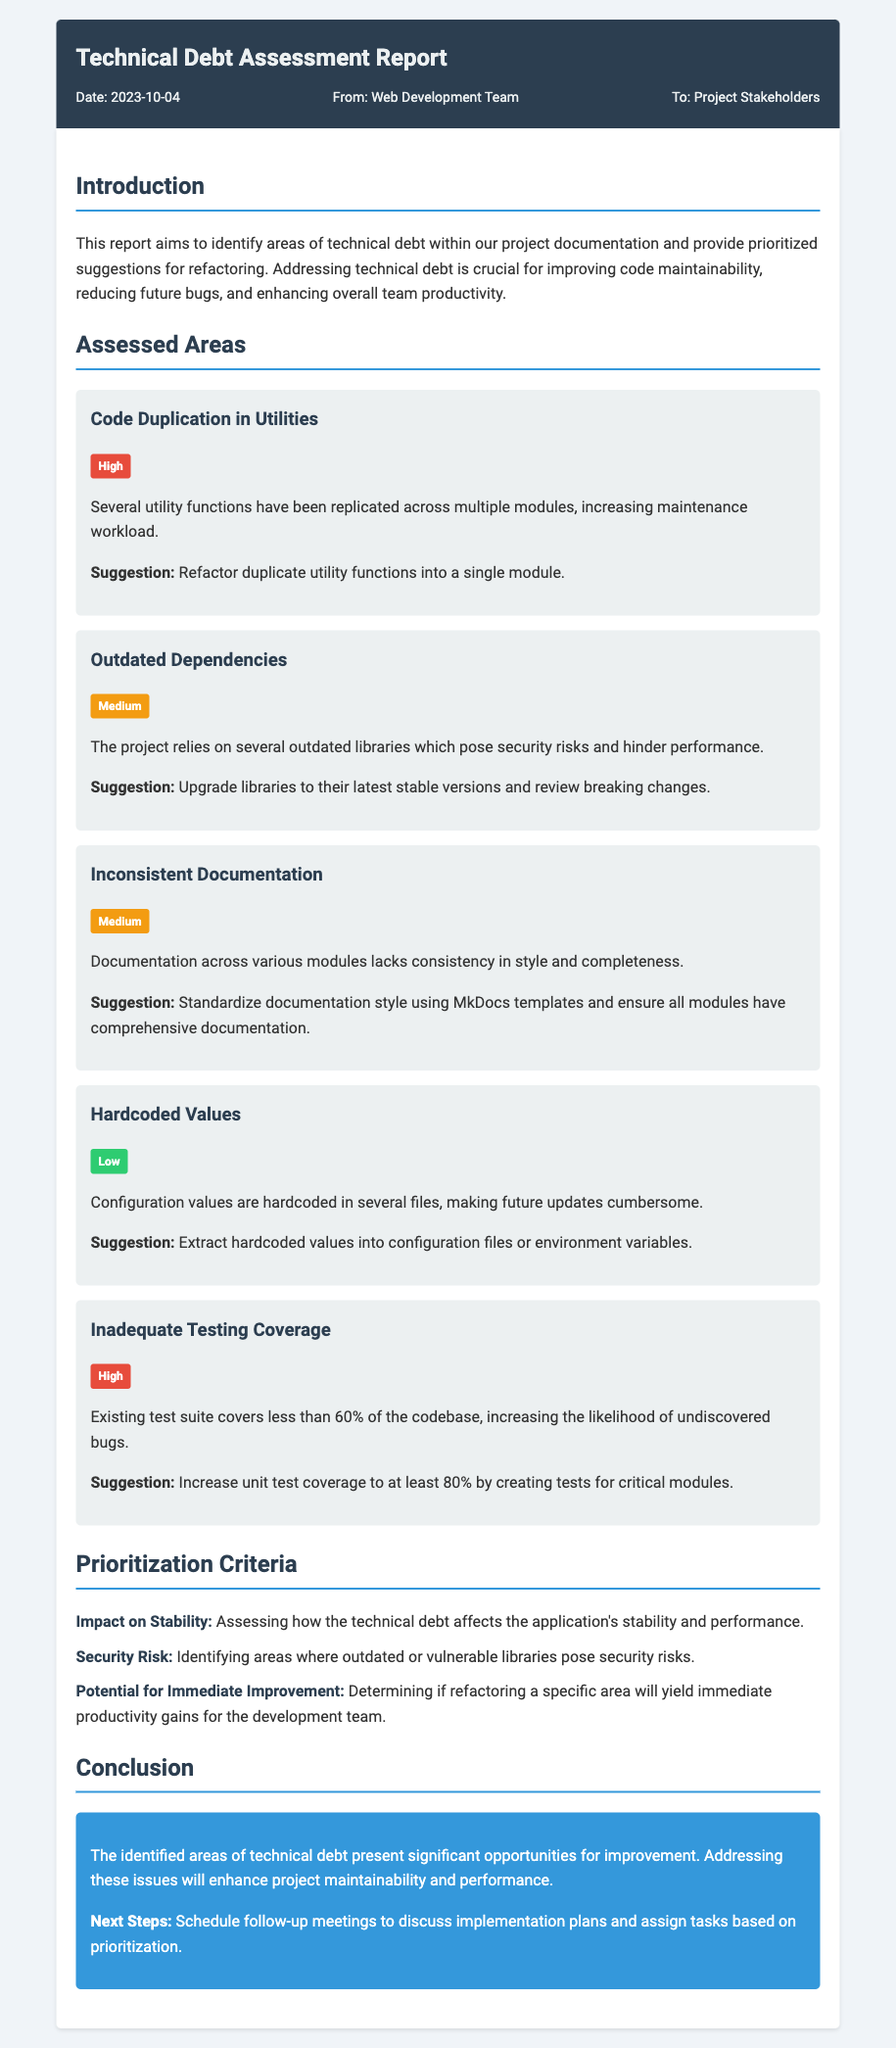What is the date of the report? The date of the report is mentioned in the memo metadata section, which states "Date: 2023-10-04."
Answer: 2023-10-04 Who is the report addressed to? The "To" section of the memo indicates that the report is directed towards "Project Stakeholders."
Answer: Project Stakeholders What area is assessed with high technical debt related to testing? The "Inadequate Testing Coverage" area is labeled with a high debt level, indicating significant issues in testing.
Answer: Inadequate Testing Coverage What suggestion is given for outdated dependencies? The suggestion for outdated dependencies is to "Upgrade libraries to their latest stable versions and review breaking changes."
Answer: Upgrade libraries How many criteria are listed for prioritization? The document lists three criteria for prioritization in the corresponding section.
Answer: Three What is the main reason for addressing technical debt according to the introduction? The introduction states that addressing technical debt is crucial for "improving code maintainability."
Answer: Improving code maintainability What is the suggestion for hardcoded values? The document suggests to "Extract hardcoded values into configuration files or environment variables."
Answer: Extract hardcoded values What is the conclusion's main focus? The conclusion emphasizes significant opportunities for improvement by addressing identified areas of technical debt.
Answer: Opportunities for improvement 